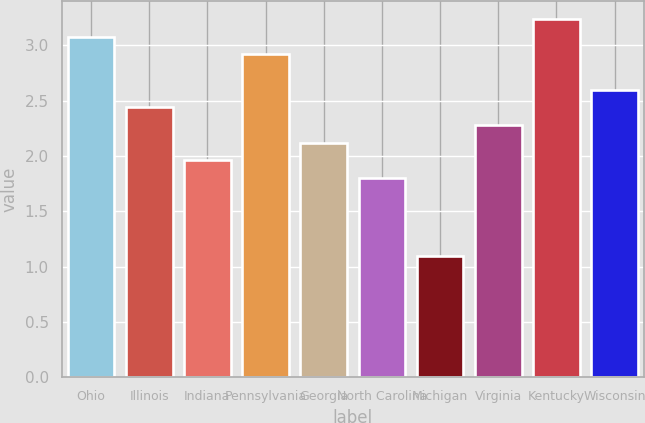<chart> <loc_0><loc_0><loc_500><loc_500><bar_chart><fcel>Ohio<fcel>Illinois<fcel>Indiana<fcel>Pennsylvania<fcel>Georgia<fcel>North Carolina<fcel>Michigan<fcel>Virginia<fcel>Kentucky<fcel>Wisconsin<nl><fcel>3.08<fcel>2.44<fcel>1.96<fcel>2.92<fcel>2.12<fcel>1.8<fcel>1.1<fcel>2.28<fcel>3.24<fcel>2.6<nl></chart> 